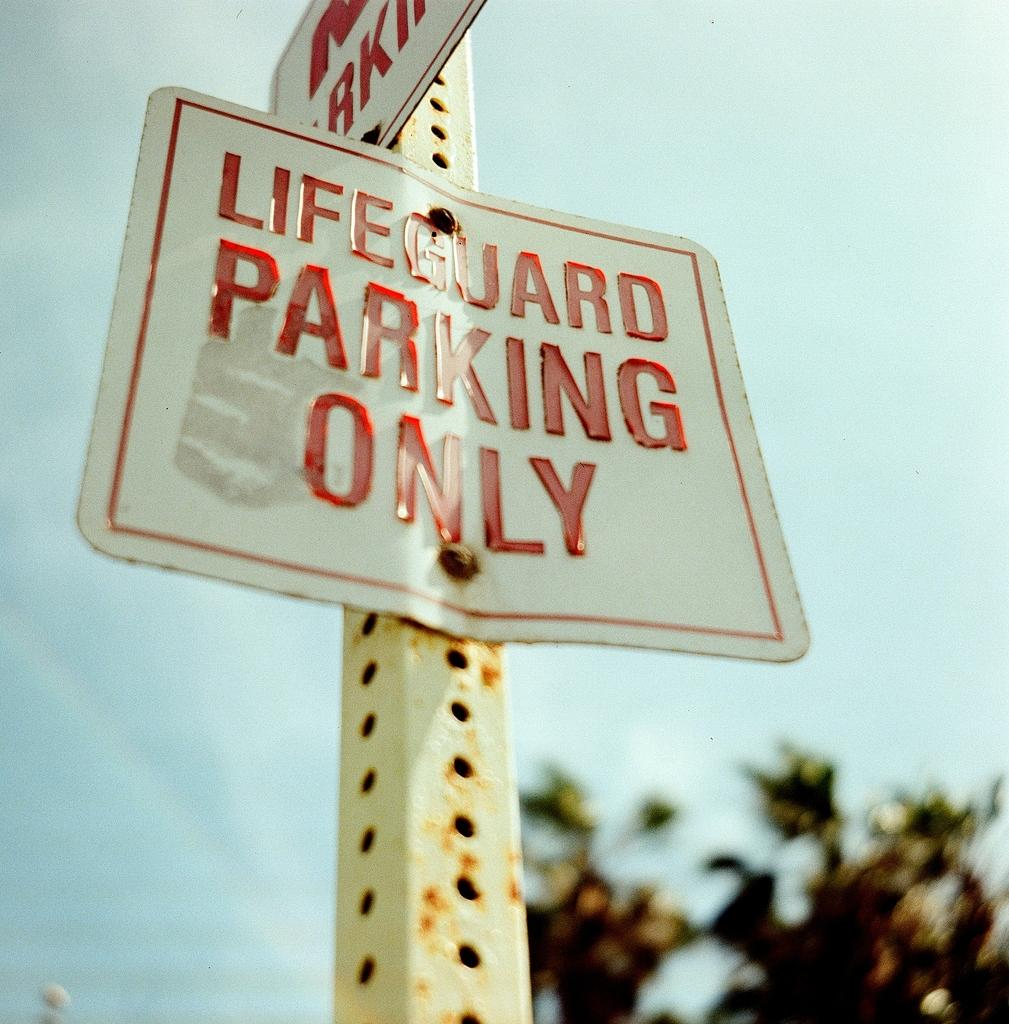Where was the picture taken? The picture was clicked outside. What can be seen in the center of the image? There are text on boards in the center of the image. How are the boards positioned in the image? The boards are attached to a metal rod. What is visible in the background of the image? There is sky and trees visible in the background of the image. What is the position of the cast in the image? There is no cast present in the image. What room is the image taken in? The image was taken outside, so it is not in a room. 